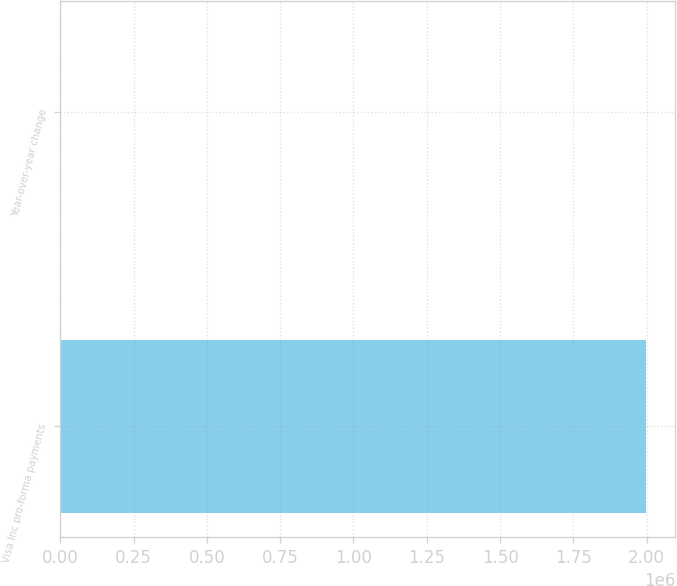Convert chart. <chart><loc_0><loc_0><loc_500><loc_500><bar_chart><fcel>Visa Inc pro-forma payments<fcel>Year-over-year change<nl><fcel>1.99745e+06<fcel>18<nl></chart> 